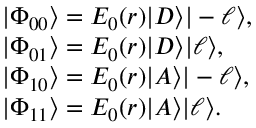<formula> <loc_0><loc_0><loc_500><loc_500>\begin{array} { r l } & { | \Phi _ { 0 0 } \rangle = E _ { 0 } ( r ) | D \rangle | - \ell \rangle , } \\ & { | \Phi _ { 0 1 } \rangle = E _ { 0 } ( r ) | D \rangle | \ell \rangle , } \\ & { | \Phi _ { 1 0 } \rangle = E _ { 0 } ( r ) | A \rangle | - \ell \rangle , } \\ & { | \Phi _ { 1 1 } \rangle = E _ { 0 } ( r ) | A \rangle | \ell \rangle . } \end{array}</formula> 